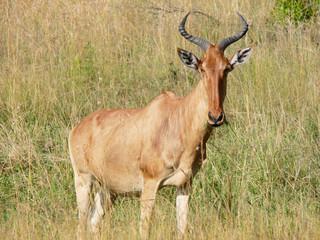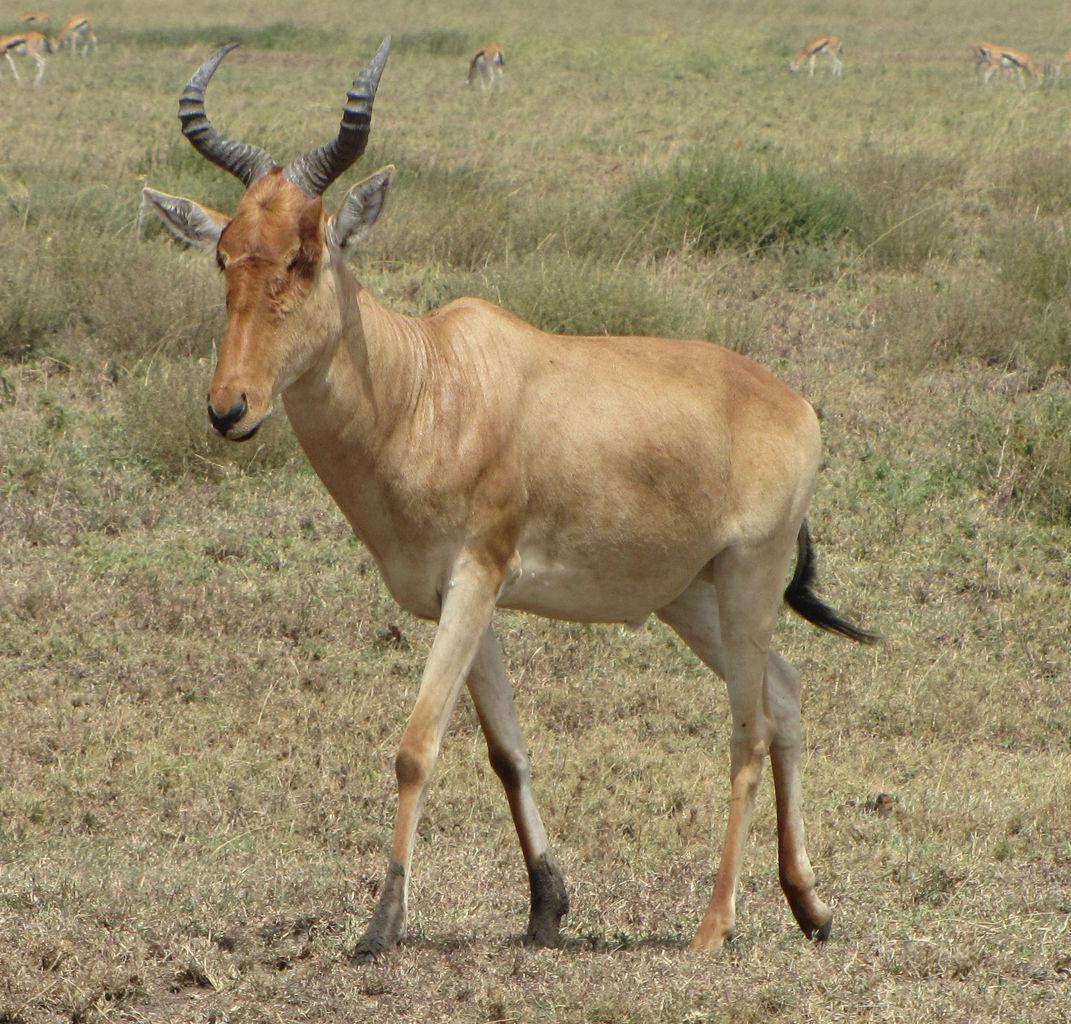The first image is the image on the left, the second image is the image on the right. For the images shown, is this caption "There are three animals." true? Answer yes or no. No. 